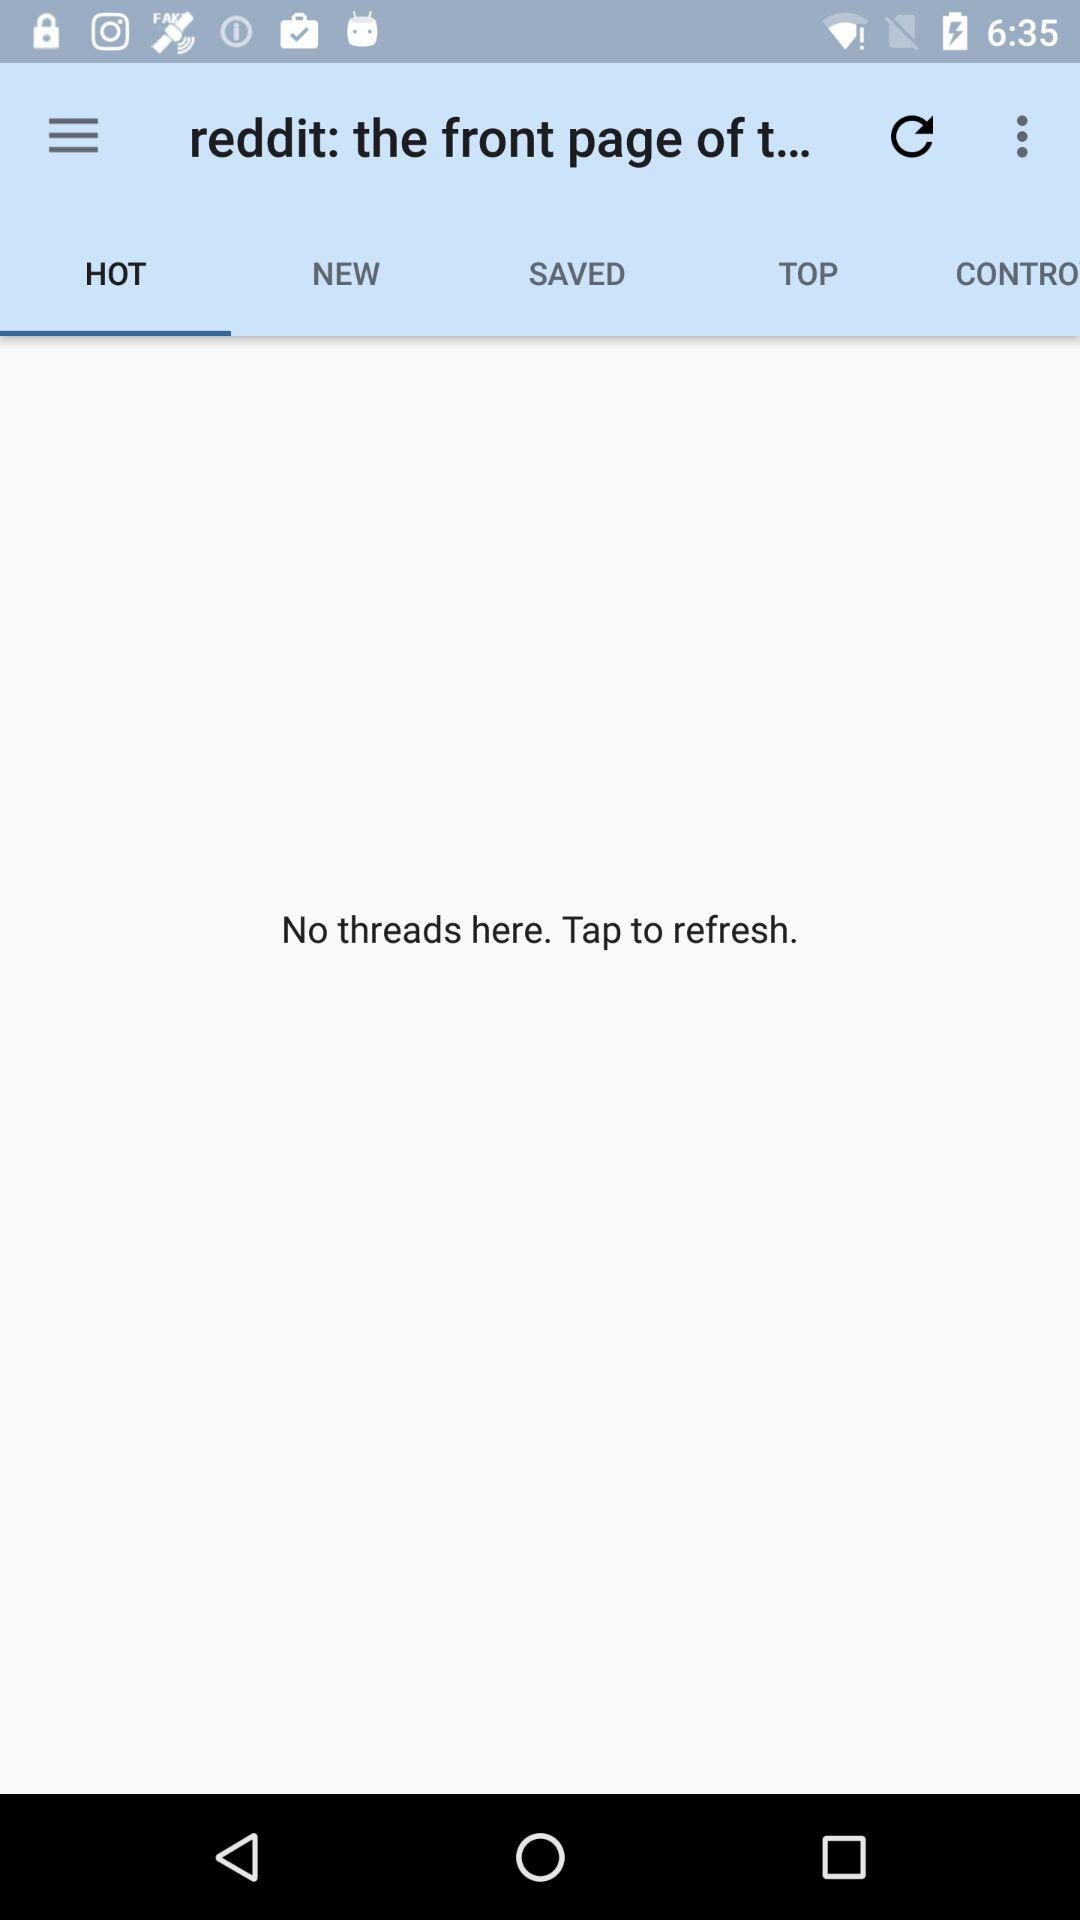Are there any threads? There are no threads. 